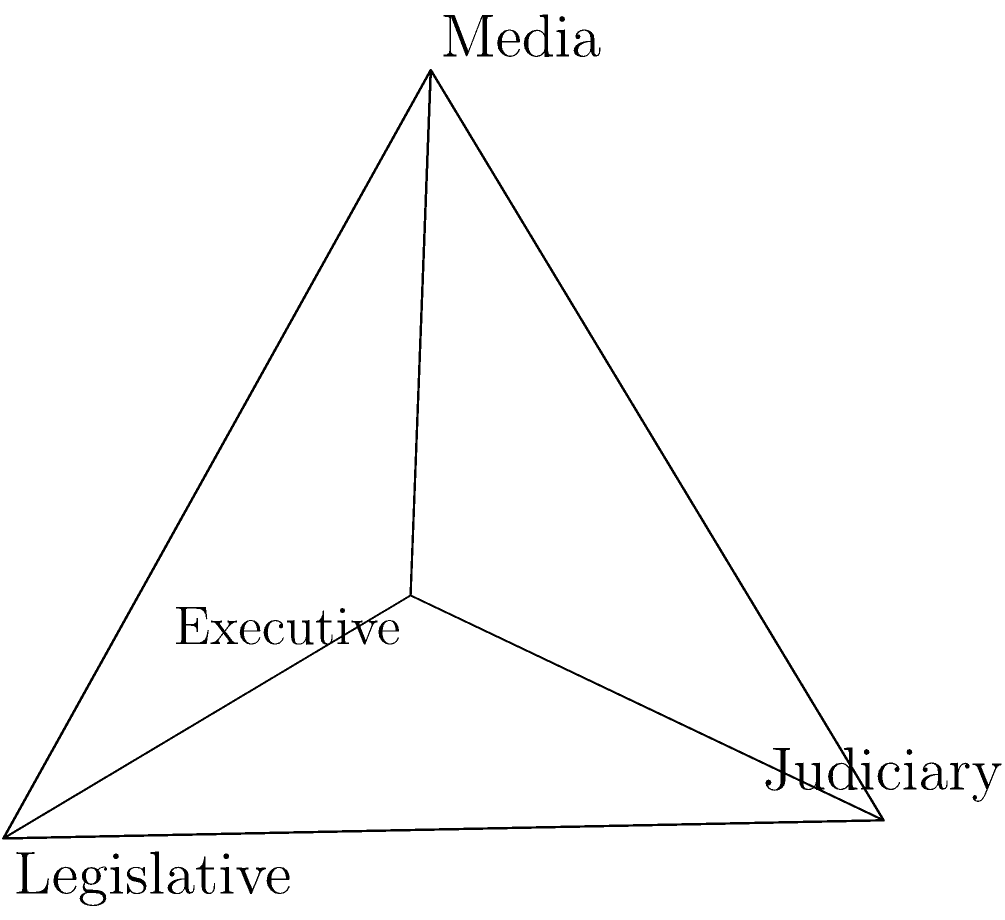In the 3D model of a nation's political structure shown above, the tetrahedron represents the balance of power between different branches. If this model is rotated 120 degrees clockwise around the vertical axis passing through the "Media" vertex, which branch will be at the front-most position, potentially symbolizing its increased influence in policy-making according to historical prophecies? To solve this problem, we need to follow these steps:

1. Identify the current orientation:
   - The "Executive" branch is at the front-bottom.
   - The "Legislative" branch is at the right-bottom.
   - The "Judiciary" branch is at the left-bottom.
   - The "Media" is at the top.

2. Understand the rotation:
   - The rotation is 120 degrees clockwise around the vertical axis through "Media".
   - This means each bottom vertex will move two positions clockwise.

3. Determine the new positions after rotation:
   - "Executive" will move to where "Judiciary" was.
   - "Legislative" will move to where "Executive" was.
   - "Judiciary" will move to where "Legislative" was.
   - "Media" remains at the top as the axis of rotation.

4. Identify the new front-most position:
   - After rotation, the "Legislative" branch will be at the front-most position.

5. Interpret the result:
   - In the context of historical prophecies influencing modern policy-making, this rotation could symbolize a shift towards increased legislative influence in the political structure.
Answer: Legislative 